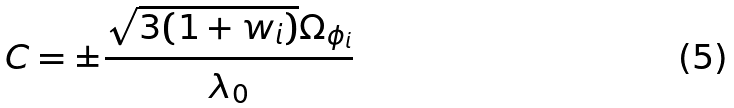<formula> <loc_0><loc_0><loc_500><loc_500>C = \pm \frac { \sqrt { 3 ( 1 + w _ { i } ) } \Omega _ { \phi _ { i } } } { \lambda _ { 0 } }</formula> 